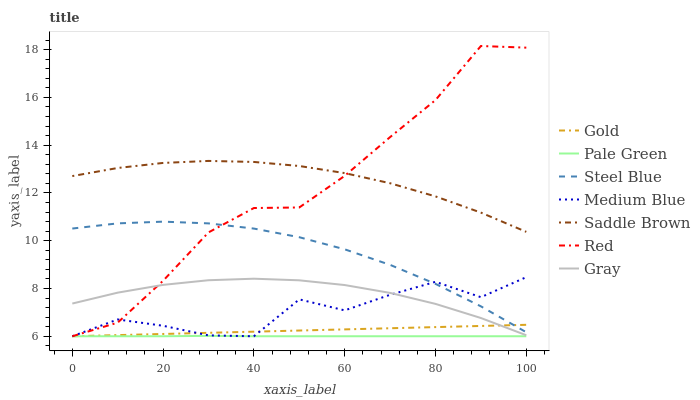Does Pale Green have the minimum area under the curve?
Answer yes or no. Yes. Does Saddle Brown have the maximum area under the curve?
Answer yes or no. Yes. Does Gold have the minimum area under the curve?
Answer yes or no. No. Does Gold have the maximum area under the curve?
Answer yes or no. No. Is Gold the smoothest?
Answer yes or no. Yes. Is Medium Blue the roughest?
Answer yes or no. Yes. Is Medium Blue the smoothest?
Answer yes or no. No. Is Gold the roughest?
Answer yes or no. No. Does Steel Blue have the lowest value?
Answer yes or no. No. Does Red have the highest value?
Answer yes or no. Yes. Does Gold have the highest value?
Answer yes or no. No. Is Medium Blue less than Saddle Brown?
Answer yes or no. Yes. Is Gray greater than Pale Green?
Answer yes or no. Yes. Does Steel Blue intersect Red?
Answer yes or no. Yes. Is Steel Blue less than Red?
Answer yes or no. No. Is Steel Blue greater than Red?
Answer yes or no. No. Does Medium Blue intersect Saddle Brown?
Answer yes or no. No. 